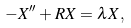<formula> <loc_0><loc_0><loc_500><loc_500>- X ^ { \prime \prime } + R X = \lambda X ,</formula> 